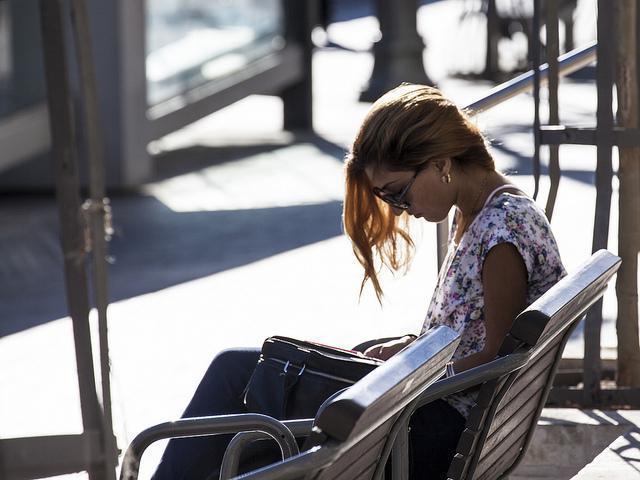How many chairs can you see?
Give a very brief answer. 2. 